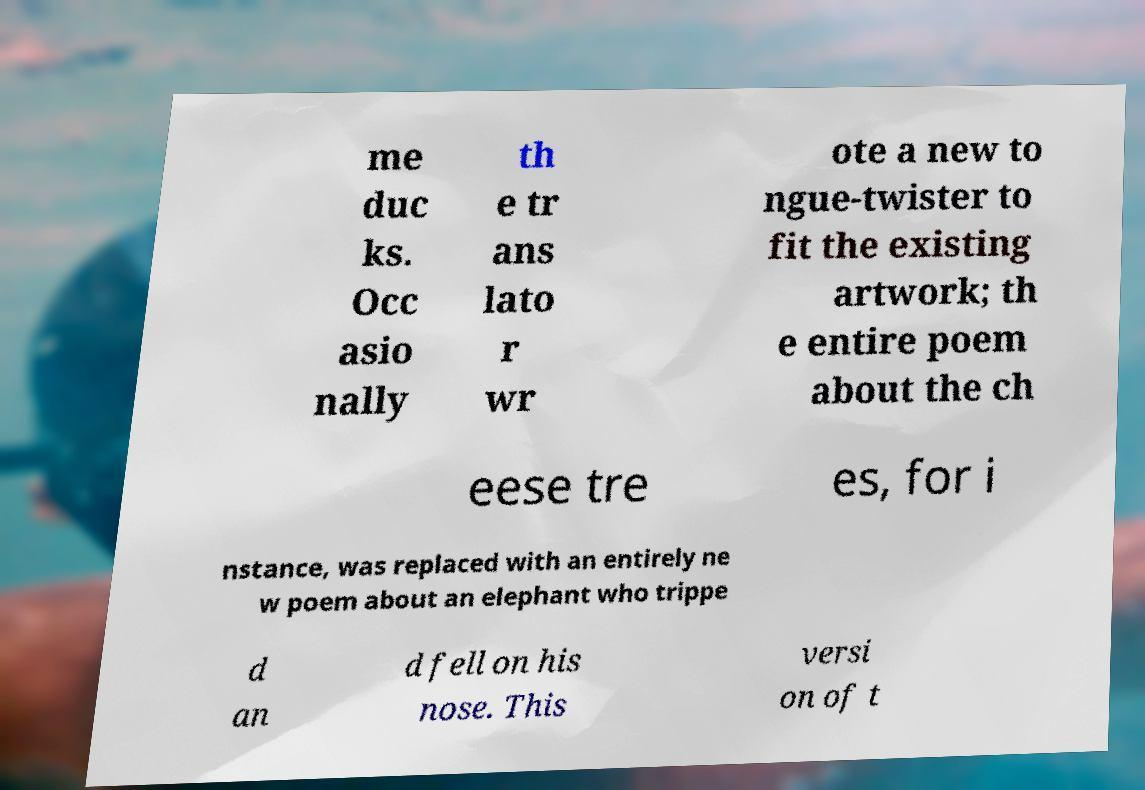Could you assist in decoding the text presented in this image and type it out clearly? me duc ks. Occ asio nally th e tr ans lato r wr ote a new to ngue-twister to fit the existing artwork; th e entire poem about the ch eese tre es, for i nstance, was replaced with an entirely ne w poem about an elephant who trippe d an d fell on his nose. This versi on of t 